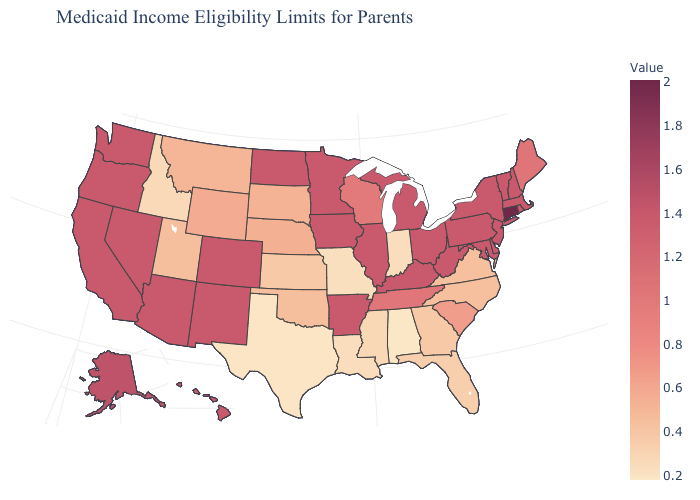Is the legend a continuous bar?
Be succinct. Yes. Which states have the highest value in the USA?
Keep it brief. Connecticut. Among the states that border Kansas , which have the highest value?
Write a very short answer. Colorado. Is the legend a continuous bar?
Be succinct. Yes. Does North Dakota have the highest value in the USA?
Quick response, please. No. Does New Mexico have the highest value in the USA?
Answer briefly. No. Does Idaho have the lowest value in the West?
Concise answer only. Yes. 